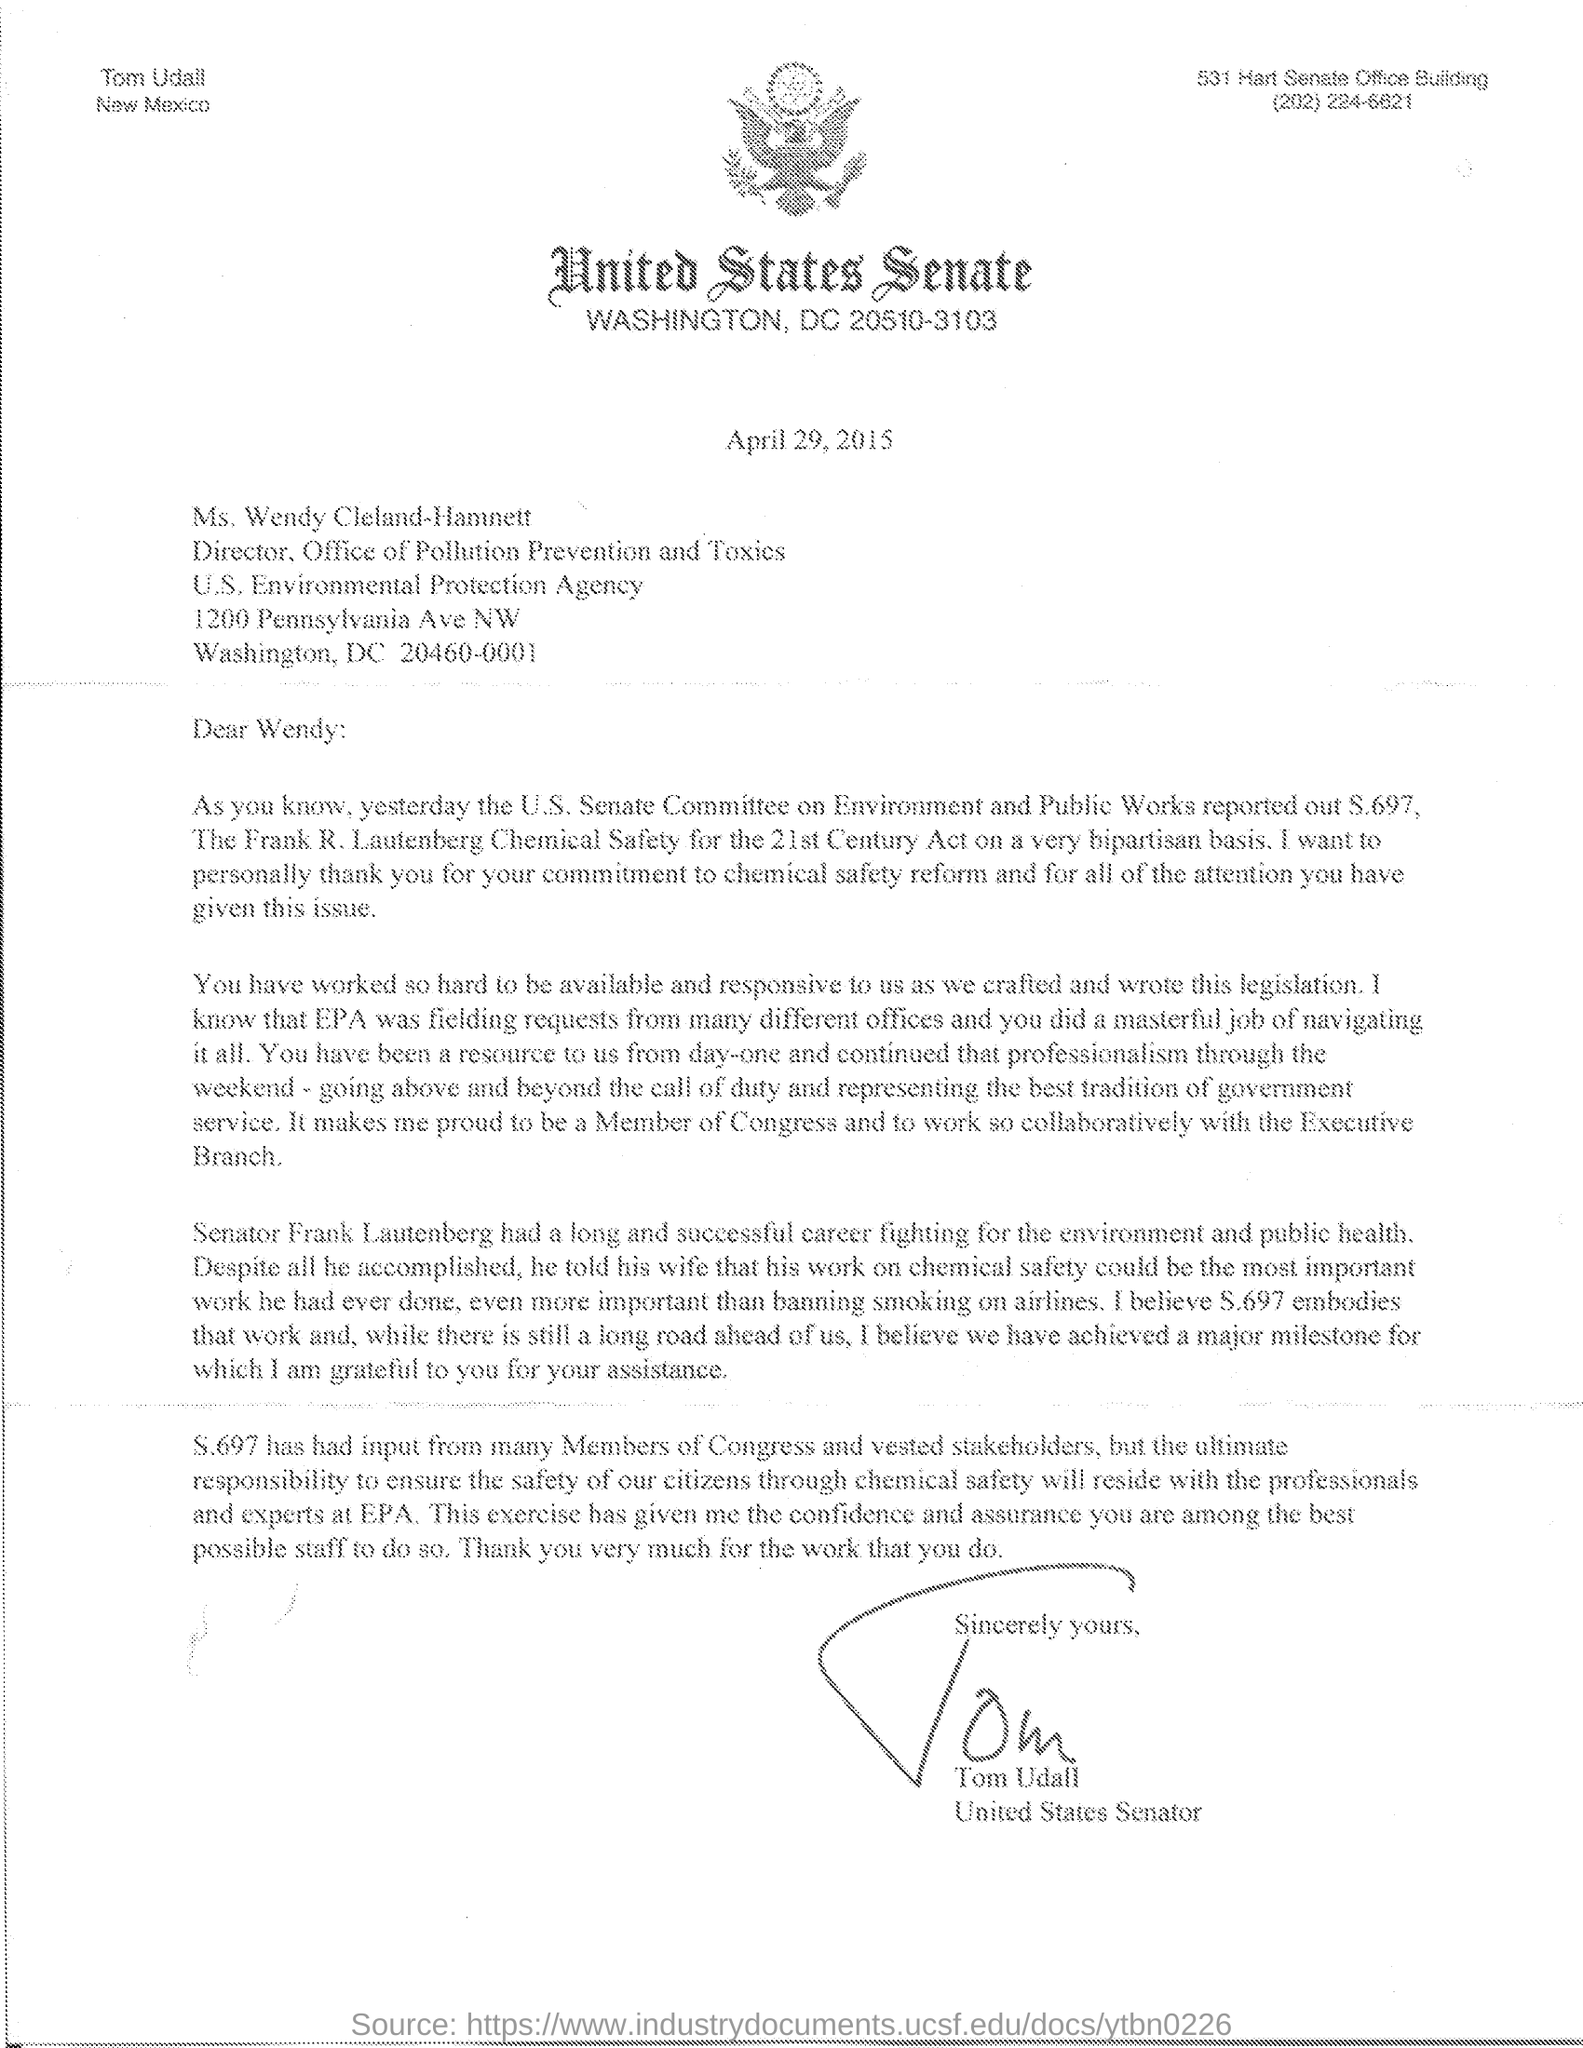Give some essential details in this illustration. Senator Frank Lautenberg had a long and successful career fighting for the environment and public health, thereby making a significant contribution to the betterment of society. The addressee of this letter is Wendy. Ms. Wendy Cleland-Hamnett holds the designation of Director of the Office of Pollution Prevention and Toxics. This letter is dated April 29, 2015. Tom Udall is a United States Senator. 